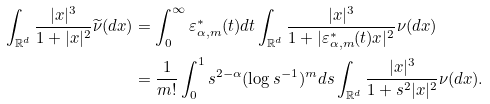Convert formula to latex. <formula><loc_0><loc_0><loc_500><loc_500>\int _ { \mathbb { R } ^ { d } } \frac { | x | ^ { 3 } } { 1 + | x | ^ { 2 } } \widetilde { \nu } ( d x ) & = \int _ { 0 } ^ { \infty } \varepsilon _ { \alpha , m } ^ { \ast } ( t ) d t \int _ { \mathbb { R } ^ { d } } \frac { | x | ^ { 3 } } { 1 + | \varepsilon _ { \alpha , m } ^ { \ast } ( t ) x | ^ { 2 } } \nu ( d x ) \\ & = \frac { 1 } { m ! } \int _ { 0 } ^ { 1 } s ^ { 2 - \alpha } ( \log s ^ { - 1 } ) ^ { m } d s \int _ { \mathbb { R } ^ { d } } \frac { | x | ^ { 3 } } { 1 + s ^ { 2 } | x | ^ { 2 } } \nu ( d x ) .</formula> 